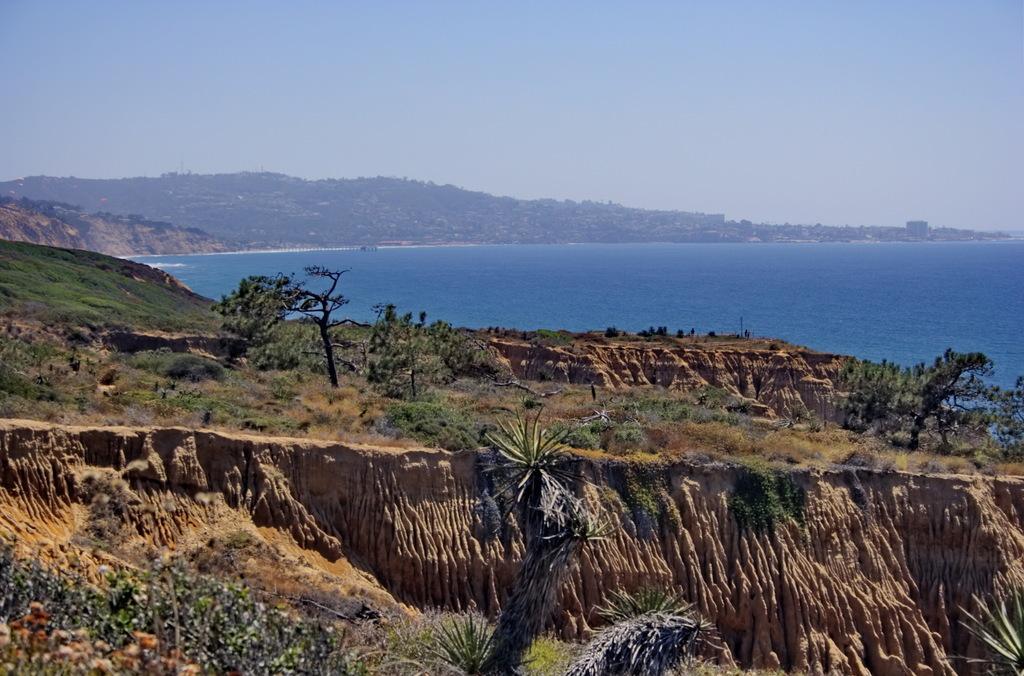Could you give a brief overview of what you see in this image? In this image I can see many trees and the grass. In the background I can see the water, mountains and the sky. 